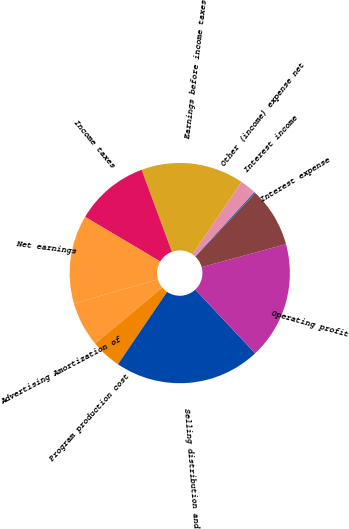<chart> <loc_0><loc_0><loc_500><loc_500><pie_chart><fcel>Advertising Amortization of<fcel>Program production cost<fcel>Selling distribution and<fcel>Operating profit<fcel>Interest expense<fcel>Interest income<fcel>Other (income) expense net<fcel>Earnings before income taxes<fcel>Income taxes<fcel>Net earnings<nl><fcel>6.6%<fcel>4.47%<fcel>21.48%<fcel>17.23%<fcel>8.72%<fcel>0.22%<fcel>2.35%<fcel>15.1%<fcel>10.85%<fcel>12.98%<nl></chart> 